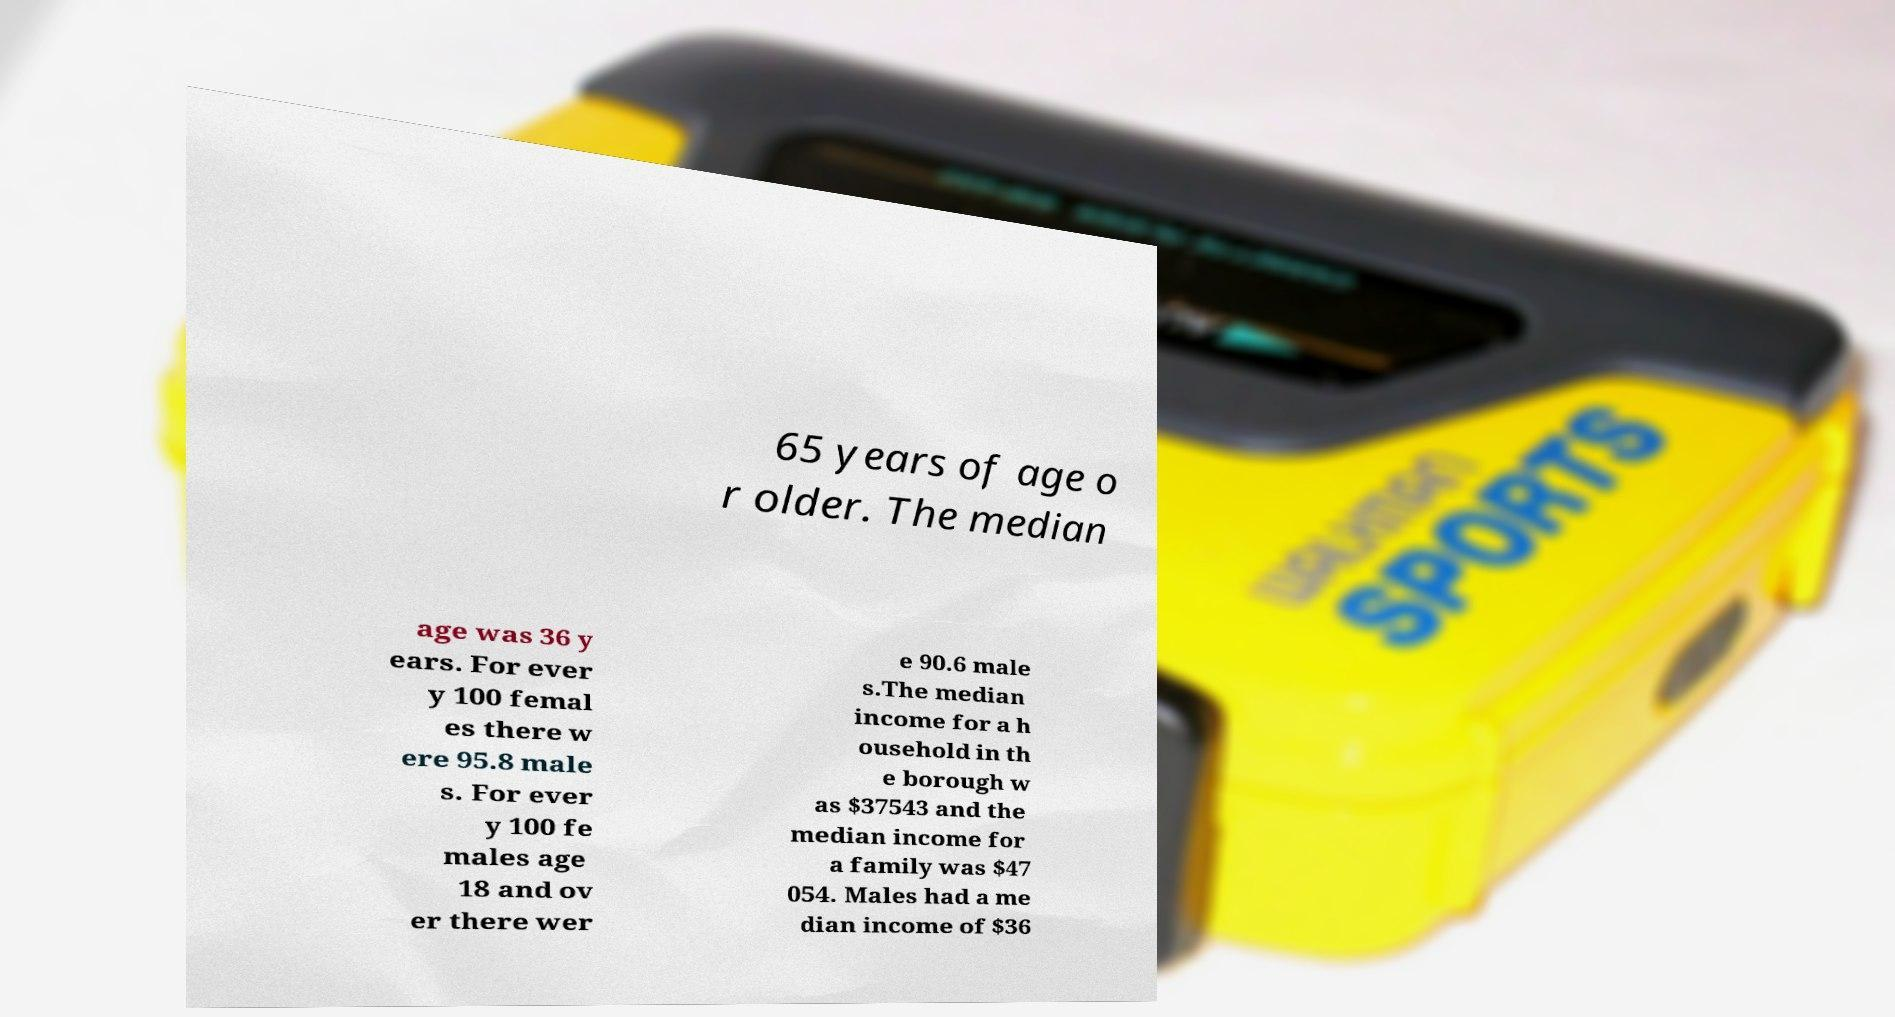I need the written content from this picture converted into text. Can you do that? 65 years of age o r older. The median age was 36 y ears. For ever y 100 femal es there w ere 95.8 male s. For ever y 100 fe males age 18 and ov er there wer e 90.6 male s.The median income for a h ousehold in th e borough w as $37543 and the median income for a family was $47 054. Males had a me dian income of $36 